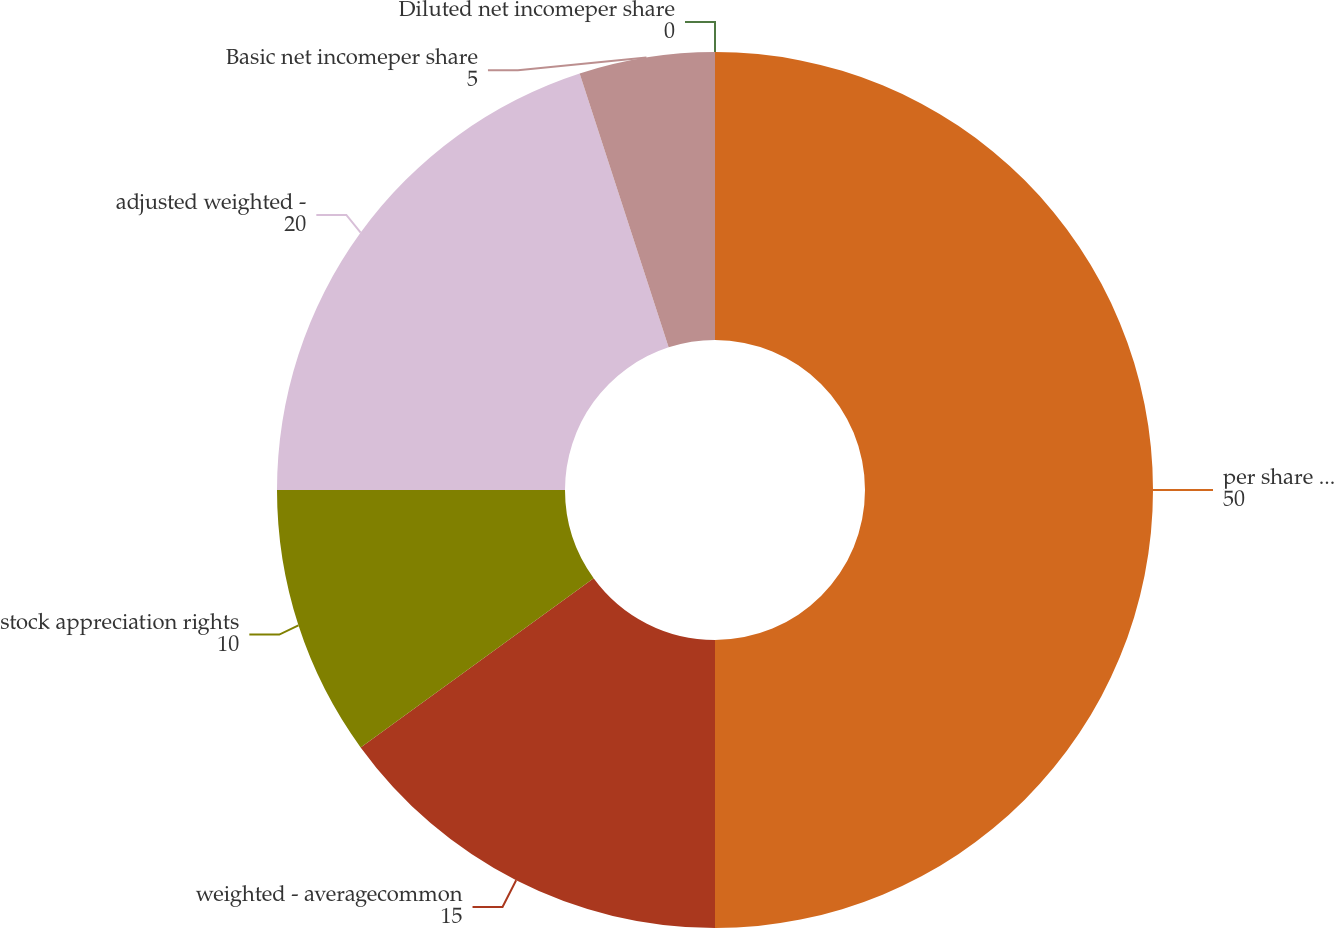Convert chart to OTSL. <chart><loc_0><loc_0><loc_500><loc_500><pie_chart><fcel>per share - net income<fcel>weighted - averagecommon<fcel>stock appreciation rights<fcel>adjusted weighted -<fcel>Basic net incomeper share<fcel>Diluted net incomeper share<nl><fcel>50.0%<fcel>15.0%<fcel>10.0%<fcel>20.0%<fcel>5.0%<fcel>0.0%<nl></chart> 